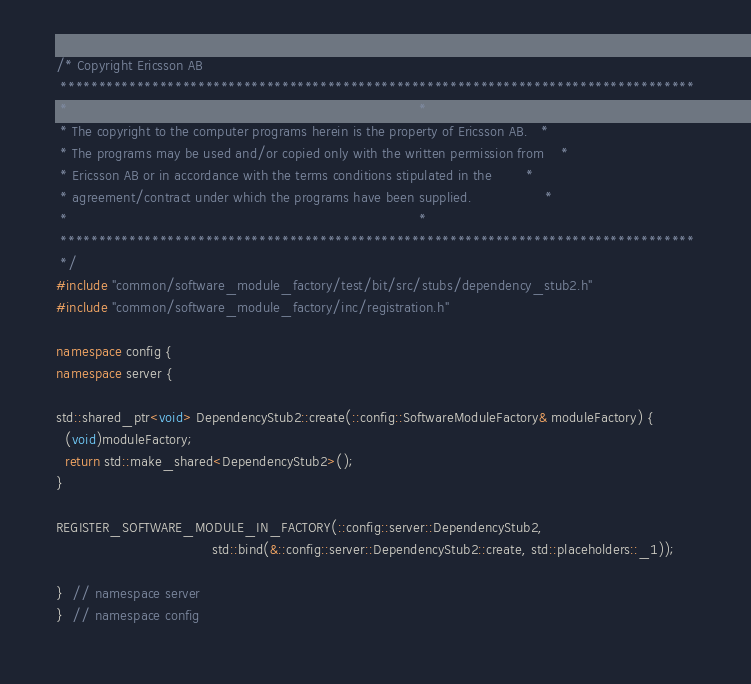<code> <loc_0><loc_0><loc_500><loc_500><_C++_>/* Copyright Ericsson AB
 ***********************************************************************************
 *                                                                                 *
 * The copyright to the computer programs herein is the property of Ericsson AB.   *
 * The programs may be used and/or copied only with the written permission from    *
 * Ericsson AB or in accordance with the terms conditions stipulated in the        *
 * agreement/contract under which the programs have been supplied.                 *
 *                                                                                 *
 ***********************************************************************************
 */
#include "common/software_module_factory/test/bit/src/stubs/dependency_stub2.h"
#include "common/software_module_factory/inc/registration.h"

namespace config {
namespace server {

std::shared_ptr<void> DependencyStub2::create(::config::SoftwareModuleFactory& moduleFactory) {
  (void)moduleFactory;
  return std::make_shared<DependencyStub2>();
}

REGISTER_SOFTWARE_MODULE_IN_FACTORY(::config::server::DependencyStub2,
                                    std::bind(&::config::server::DependencyStub2::create, std::placeholders::_1));

}  // namespace server
}  // namespace config
</code> 